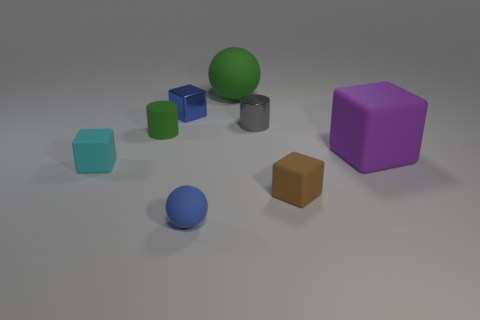How many other objects are the same size as the brown thing?
Your answer should be very brief. 5. There is a shiny thing that is on the right side of the blue block; how many tiny green rubber cylinders are on the right side of it?
Your answer should be compact. 0. There is a rubber block that is to the right of the matte cylinder and behind the brown rubber object; how big is it?
Provide a short and direct response. Large. What material is the small cylinder on the right side of the green rubber cylinder?
Your response must be concise. Metal. Are there any small blue shiny objects that have the same shape as the cyan matte thing?
Give a very brief answer. Yes. What number of small green things have the same shape as the gray object?
Give a very brief answer. 1. There is a green object behind the small gray shiny object; does it have the same size as the shiny object that is on the left side of the gray metallic cylinder?
Your response must be concise. No. The tiny rubber object to the right of the tiny blue sphere that is on the right side of the small cyan matte thing is what shape?
Your response must be concise. Cube. Are there the same number of tiny rubber balls right of the cyan cube and small cylinders?
Your answer should be very brief. No. What material is the ball that is in front of the tiny matte block that is behind the tiny matte block right of the tiny ball made of?
Your response must be concise. Rubber. 